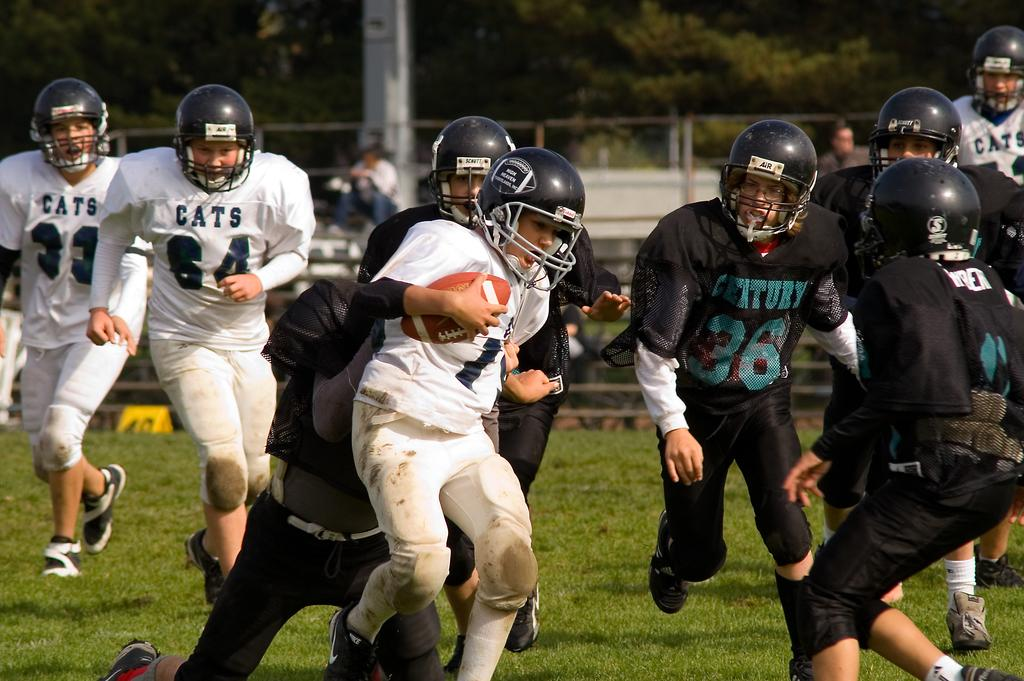What sport are the players engaged in on the ground? The players are playing rugby. What protective gear are the players wearing? They are all wearing helmets. What object is essential to the game of rugby and is visible in the image? There is a rugby ball in the image. What can be seen in the background of the image? There are trees, a boundary, and people in the background of the image. How many cats can be seen playing with a hose in the image? There are no cats or hoses present in the image; it features rugby players on a field. 